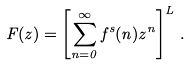Convert formula to latex. <formula><loc_0><loc_0><loc_500><loc_500>F ( z ) = \left [ \sum _ { n = 0 } ^ { \infty } f ^ { s } ( n ) z ^ { n } \right ] ^ { L } \, .</formula> 